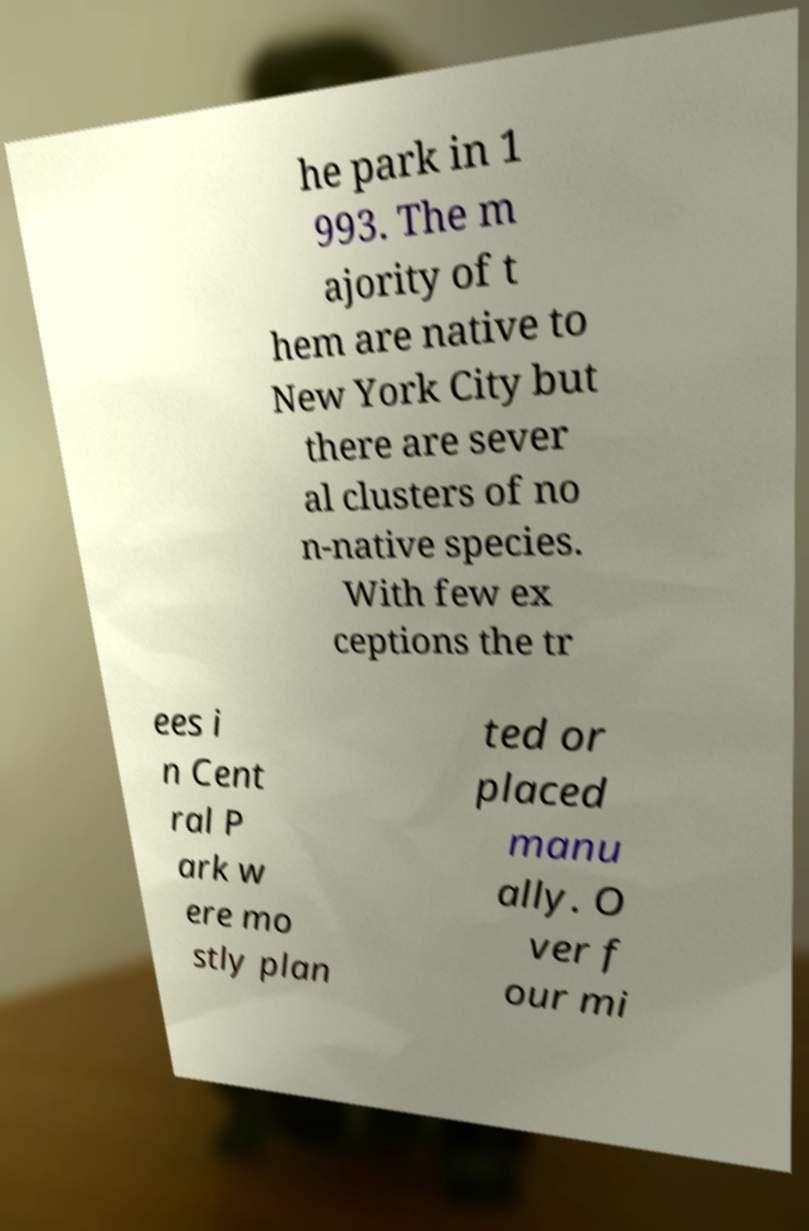I need the written content from this picture converted into text. Can you do that? he park in 1 993. The m ajority of t hem are native to New York City but there are sever al clusters of no n-native species. With few ex ceptions the tr ees i n Cent ral P ark w ere mo stly plan ted or placed manu ally. O ver f our mi 